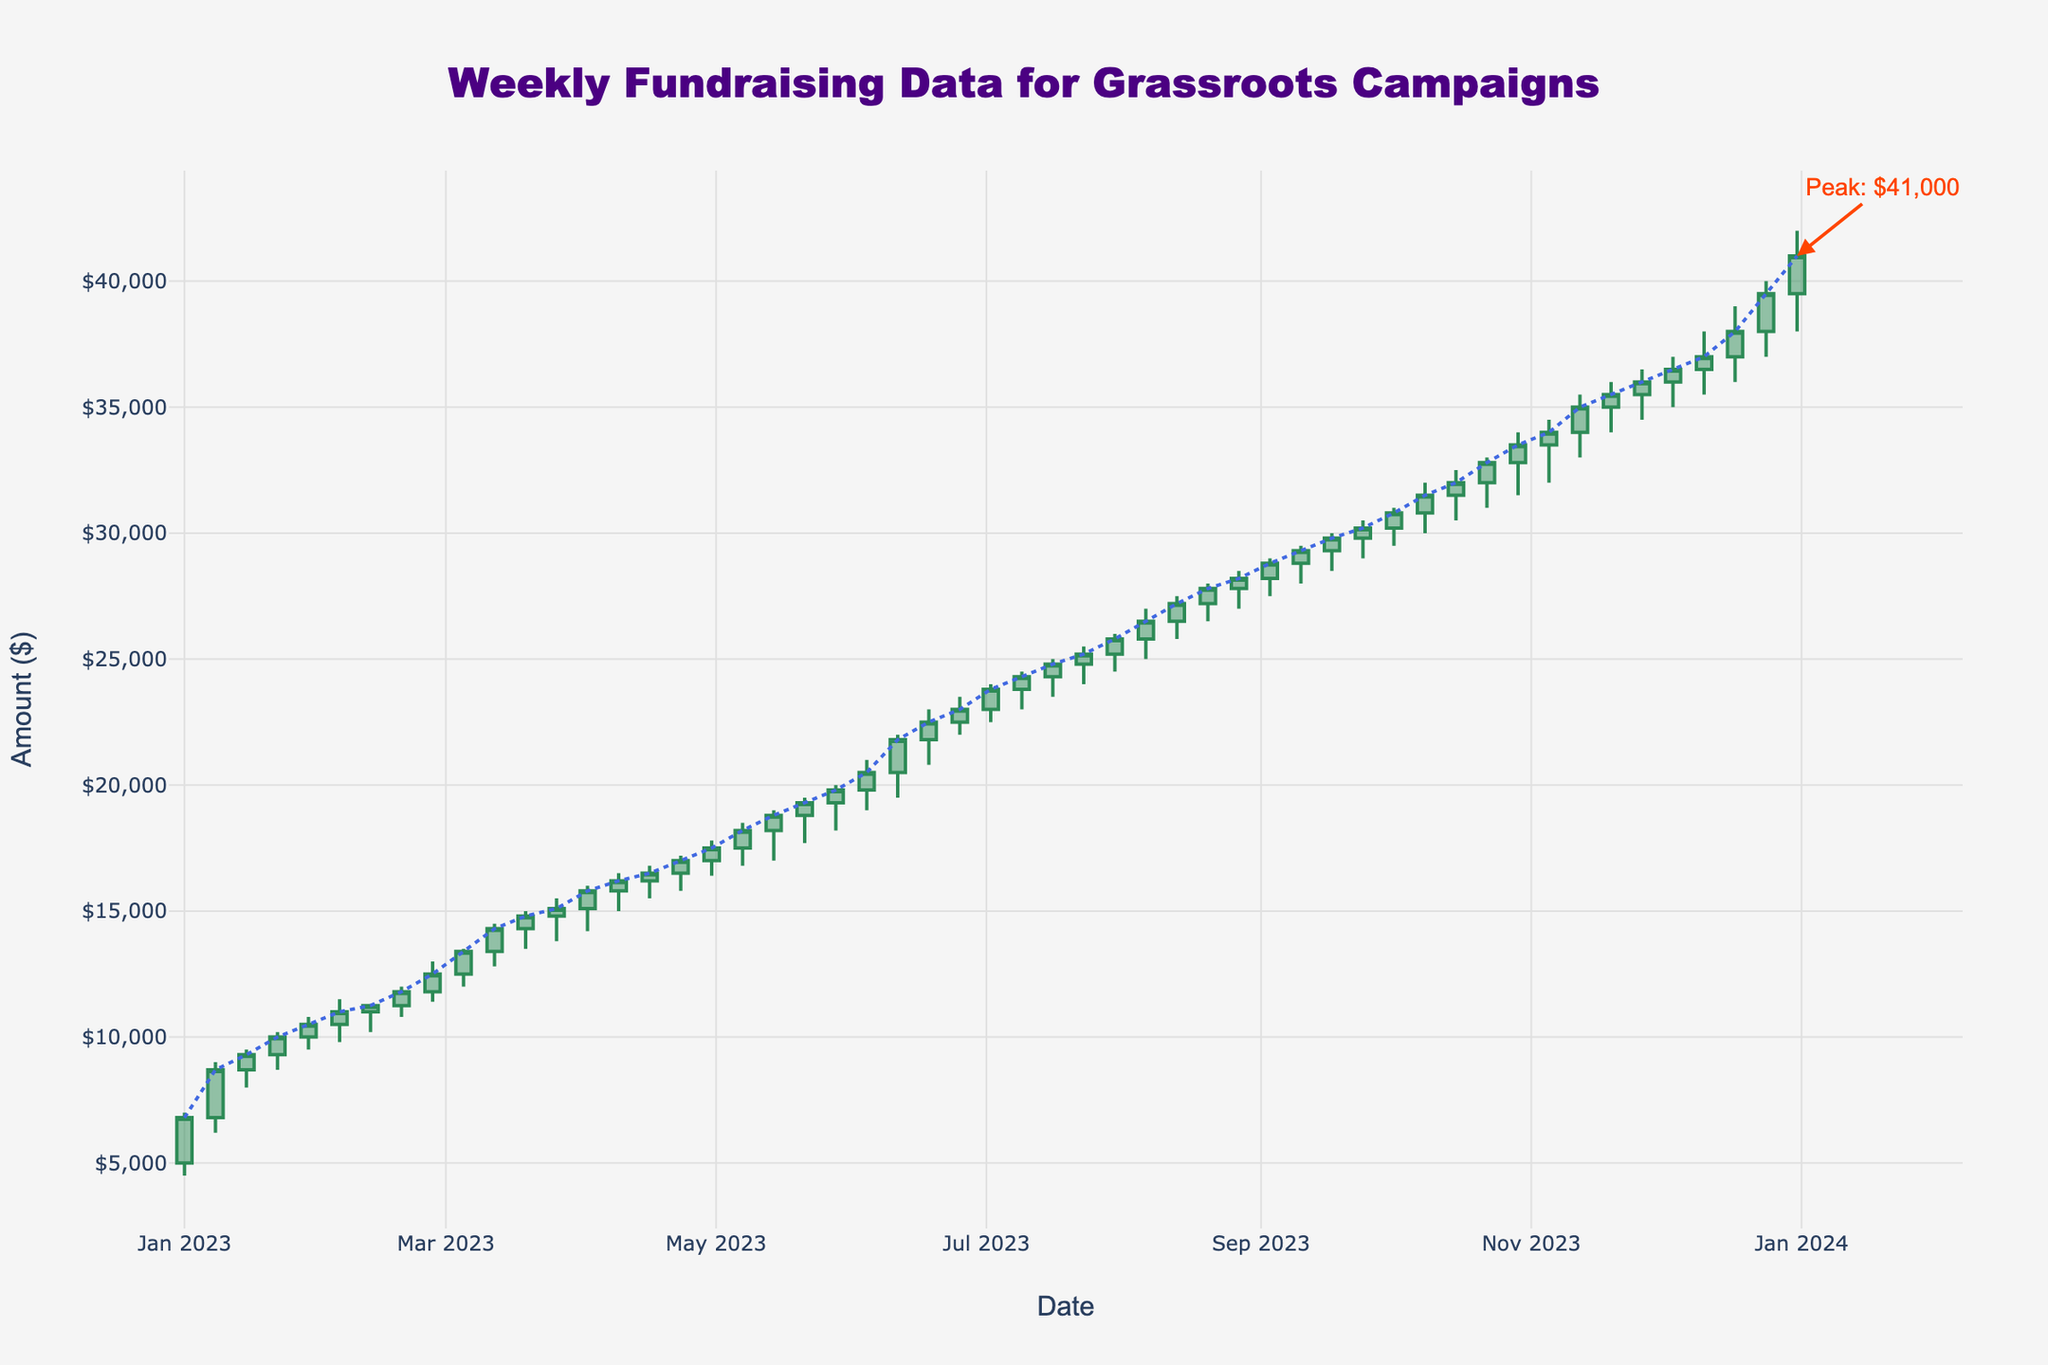What's the title of the plot? The title of the plot is centered at the top of the figure and is one of the most easily recognizable elements. It reads: "Weekly Fundraising Data for Grassroots Campaigns."
Answer: Weekly Fundraising Data for Grassroots Campaigns What is the highest fundraising amount reached according to the plot? The highest fundraising amount can be identified by looking at the peak marked by an annotation on the plot. In this case, the annotation points to a peak of $41,000.
Answer: $41,000 How many weeks are represented in the plot? The plot represents each week from January 1, 2023, to December 31, 2023. Counting these weeks on the x-axis gives the total number of weeks in a year, which is 52.
Answer: 52 What was the closing amount at the end of March 2023? To find the closing amount at the end of March 2023, we look at the candlestick for the week of March 26, 2023. The closing value at this week, highlighted at the edge of the candlestick, is $15,100.
Answer: $15,100 What was the trend of fundraising from January to April 2023? To see the trend from January to April, we can look at the general movement of the closing values along the y-axis. Initially starting from about $6,800 in January, the trend line moves upwards steadily and ends around $17,500 in April. This indicates an upward trend.
Answer: Upward trend What is the average closing amount in January 2023? To calculate the average closing amount in January 2023, sum the closing amounts ($6800, $8700, $9300, $10000, $10500) and divide by the number of weeks (5). The sum is $44900. Dividing this by 5 gives an average of $8980.
Answer: $8980 Which week had the largest range of fundraising amounts, and what is the range? To find the week with the largest range, calculate the difference between the high and low values for each week. The week of December 31, 2023, has the largest range with high $42000 and low $38000. The range is $42000 - $38000 = $4000.
Answer: Week of December 31, range $4000 During which week did the fundraising increase the most compared to the previous week? The week with the largest increase can be found by comparing the difference in closing amounts week-over-week. The week of June 11, 2023, shows a significant jump from $20500 to $21800, an increase of $1300.
Answer: Week of June 11, 2023 How does the fundraising amount in August compare to that in September? We can compare the closing amounts for weeks in August and September. The ending value in August is $28200, and for September, it's $30200. The fundraising amount increased by $2000.
Answer: Increased by $2000 What can you say about the color of the candlesticks? The colors of the candlesticks indicate whether the funds increased or decreased. Candlesticks with sea green color represent an increase (closing higher than the opening), while those in dark red indicate a decrease (closing lower than the opening).
Answer: Sea green for increase, dark red for decrease 